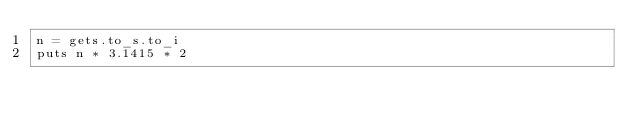Convert code to text. <code><loc_0><loc_0><loc_500><loc_500><_Crystal_>n = gets.to_s.to_i
puts n * 3.1415 * 2
</code> 